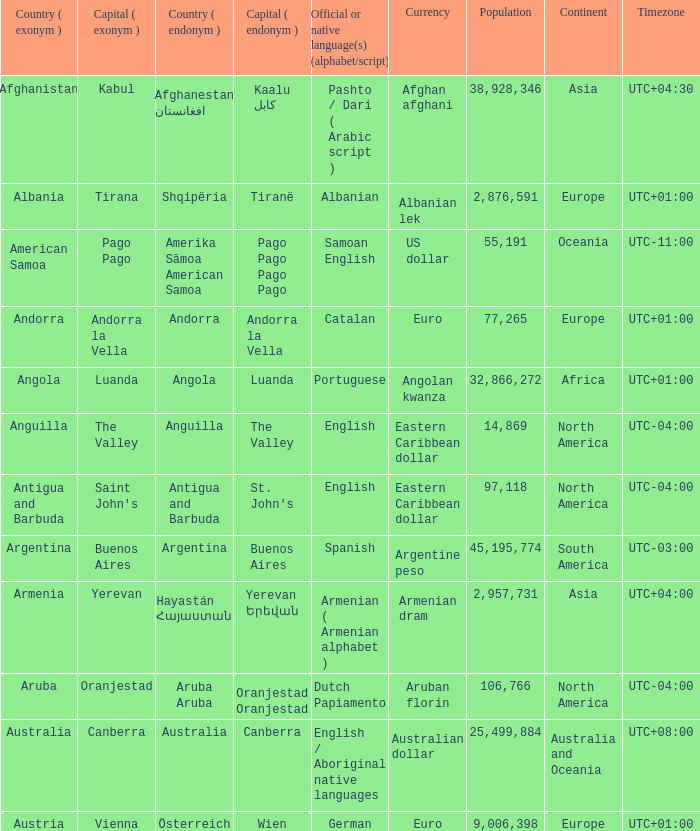What is the English name given to the city of St. John's? Saint John's. 